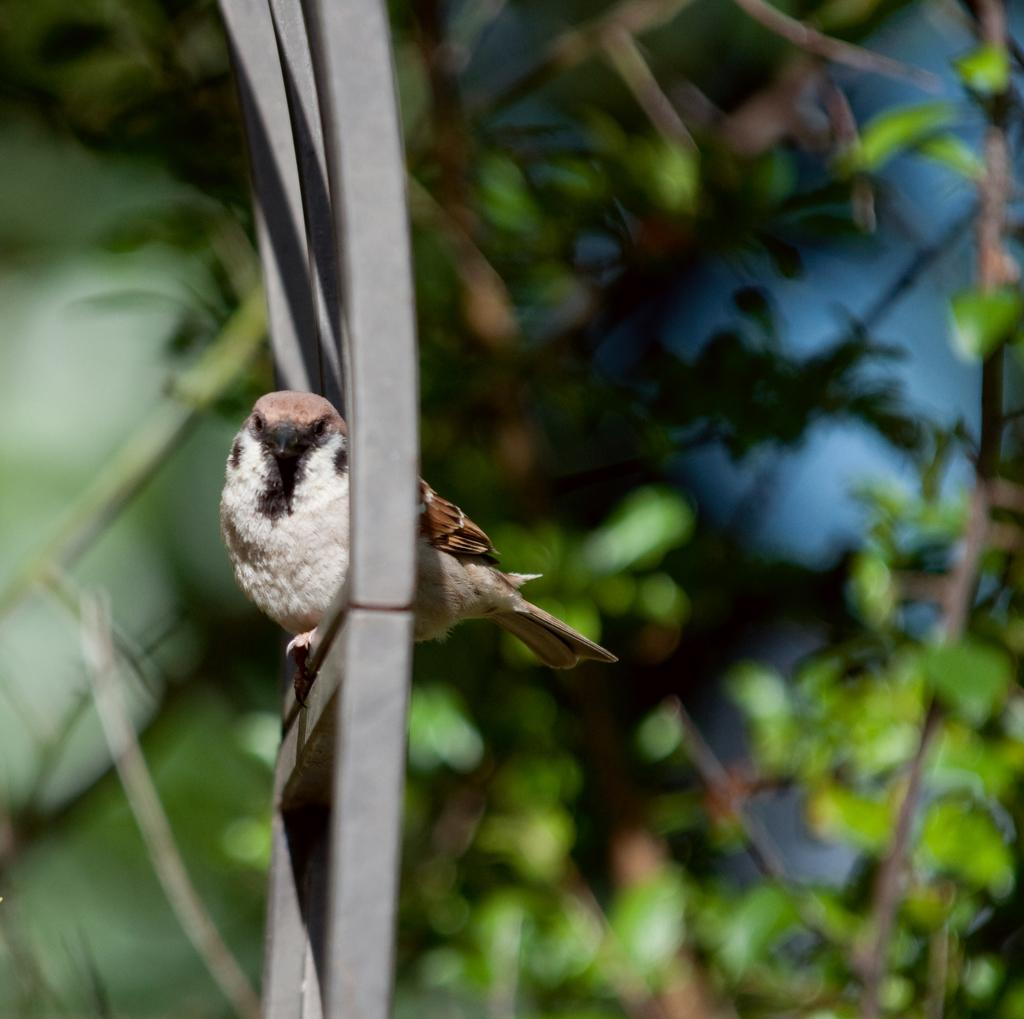What type of living organism can be seen in the image? There is a plant in the image. What animal is present in the image? There is a bird in the image. Where is the bird located in the image? The bird is sitting on a metallic object. What type of polish is the bird using to clean its feathers in the image? There is no polish present in the image, and the bird is not shown cleaning its feathers. 